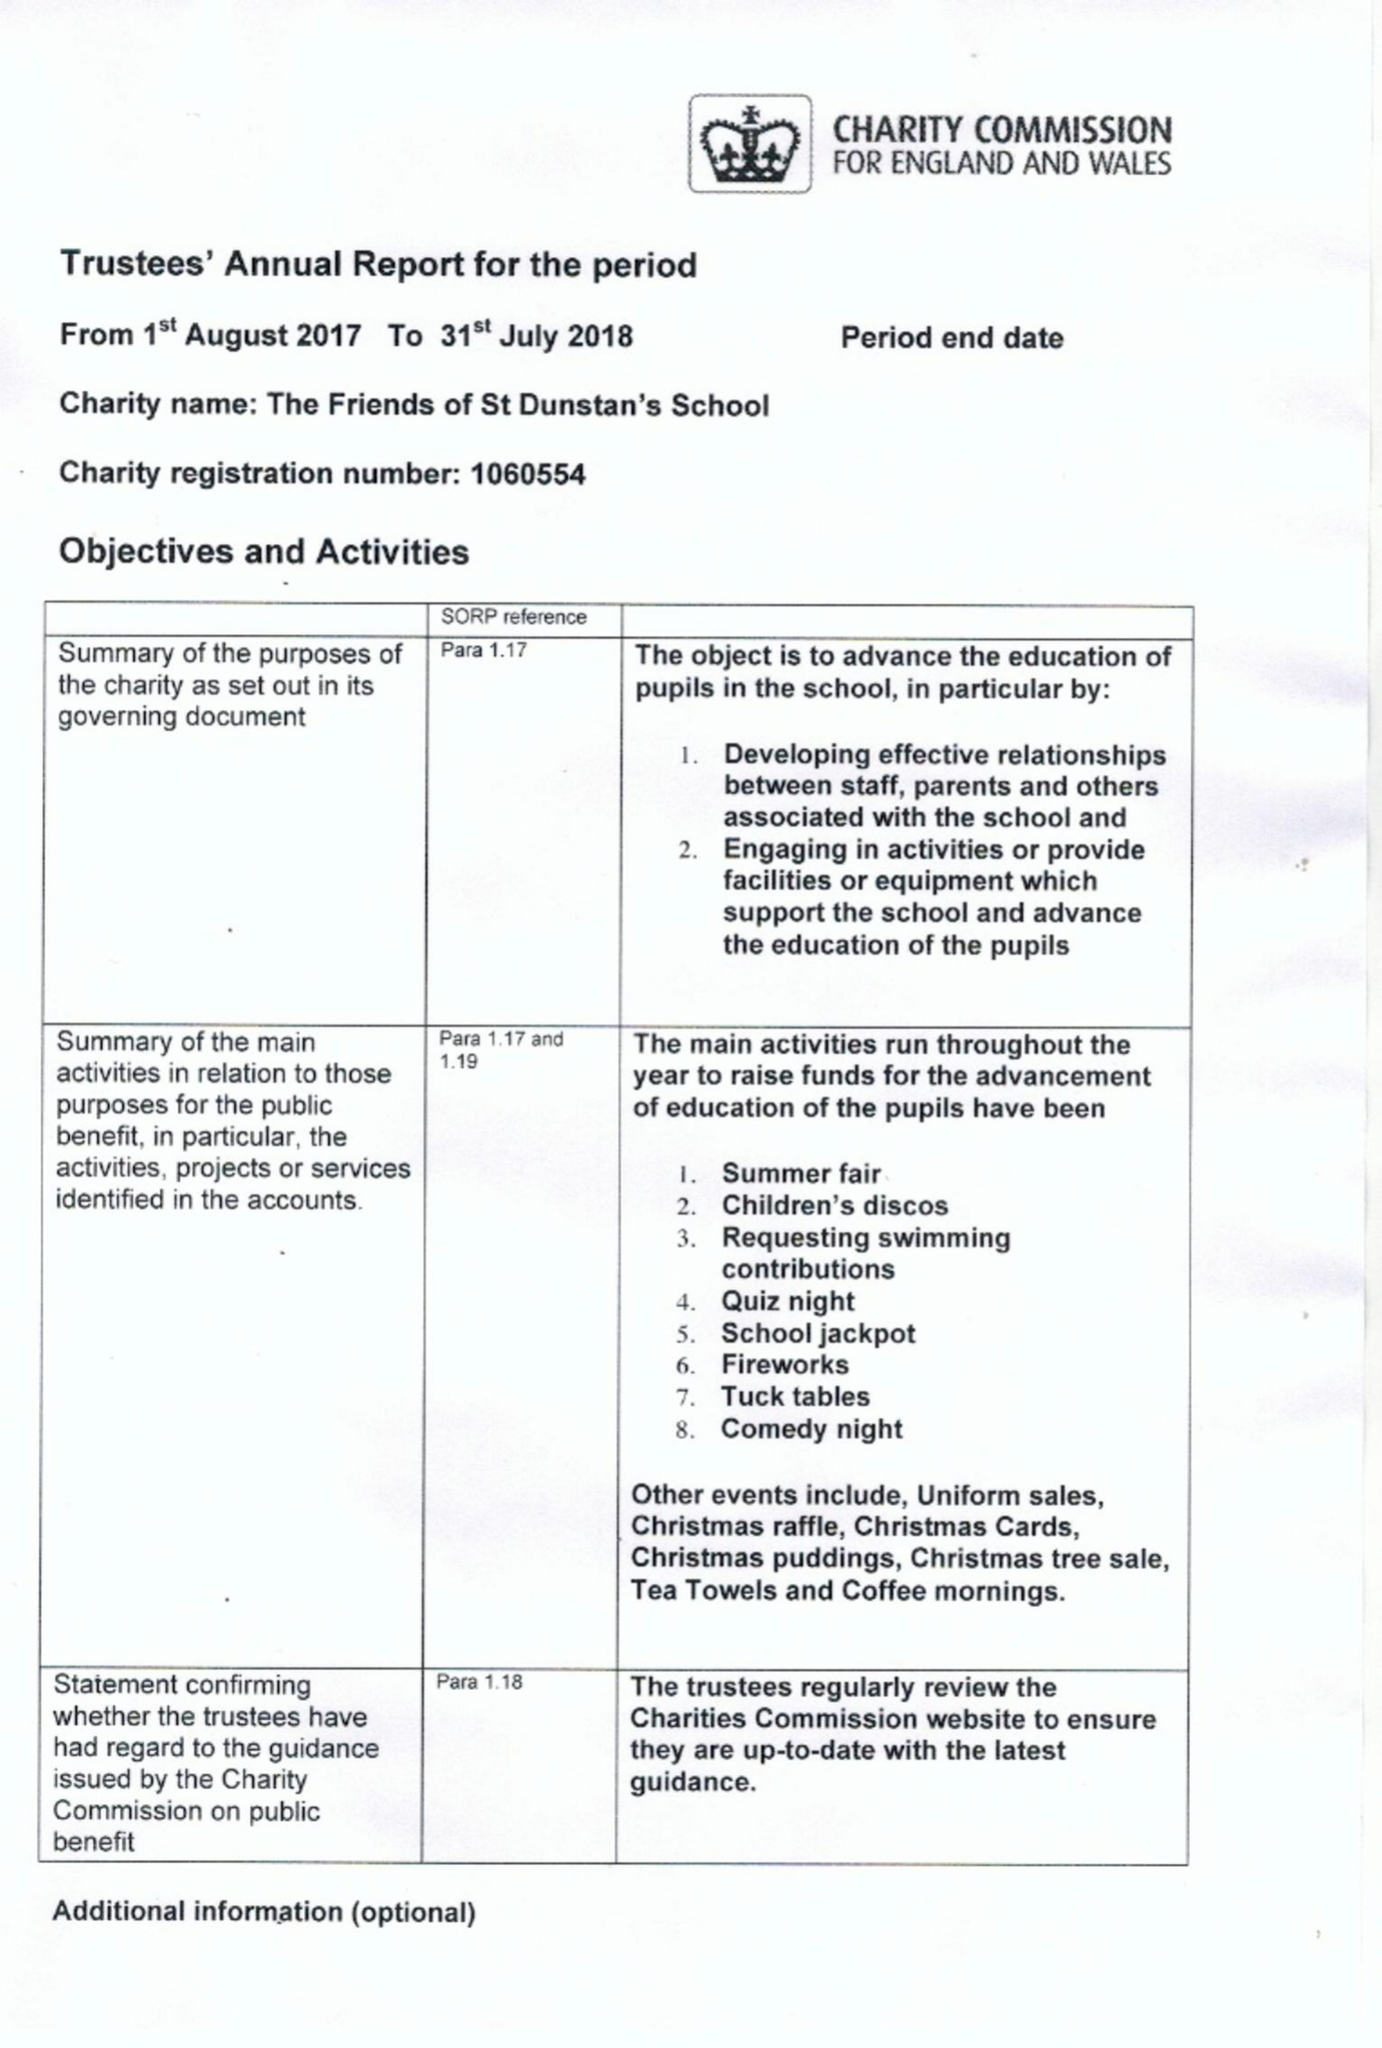What is the value for the address__postcode?
Answer the question using a single word or phrase. GU22 7AX 